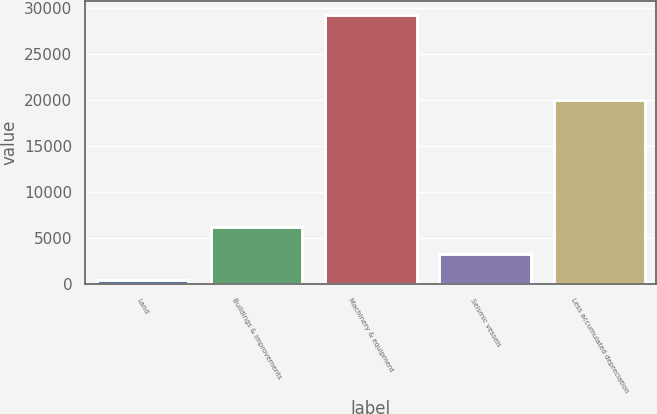<chart> <loc_0><loc_0><loc_500><loc_500><bar_chart><fcel>Land<fcel>Buildings & improvements<fcel>Machinery & equipment<fcel>Seismic vessels<fcel>Less accumulated depreciation<nl><fcel>394<fcel>6181.6<fcel>29332<fcel>3287.8<fcel>20068<nl></chart> 